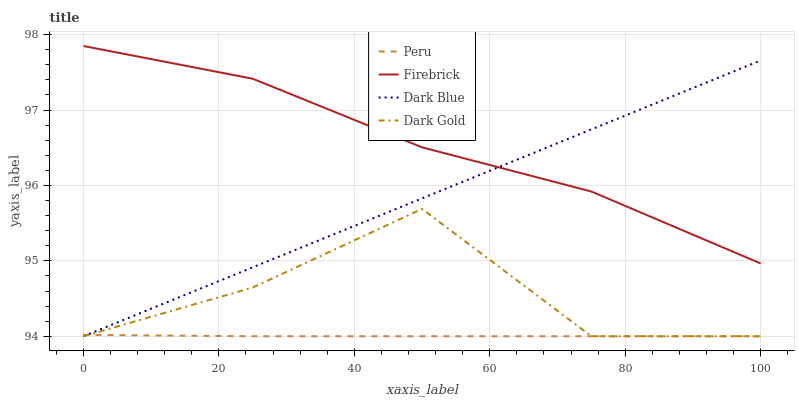Does Peru have the minimum area under the curve?
Answer yes or no. Yes. Does Firebrick have the maximum area under the curve?
Answer yes or no. Yes. Does Firebrick have the minimum area under the curve?
Answer yes or no. No. Does Peru have the maximum area under the curve?
Answer yes or no. No. Is Dark Blue the smoothest?
Answer yes or no. Yes. Is Dark Gold the roughest?
Answer yes or no. Yes. Is Firebrick the smoothest?
Answer yes or no. No. Is Firebrick the roughest?
Answer yes or no. No. Does Firebrick have the lowest value?
Answer yes or no. No. Does Peru have the highest value?
Answer yes or no. No. Is Dark Gold less than Firebrick?
Answer yes or no. Yes. Is Firebrick greater than Dark Gold?
Answer yes or no. Yes. Does Dark Gold intersect Firebrick?
Answer yes or no. No. 